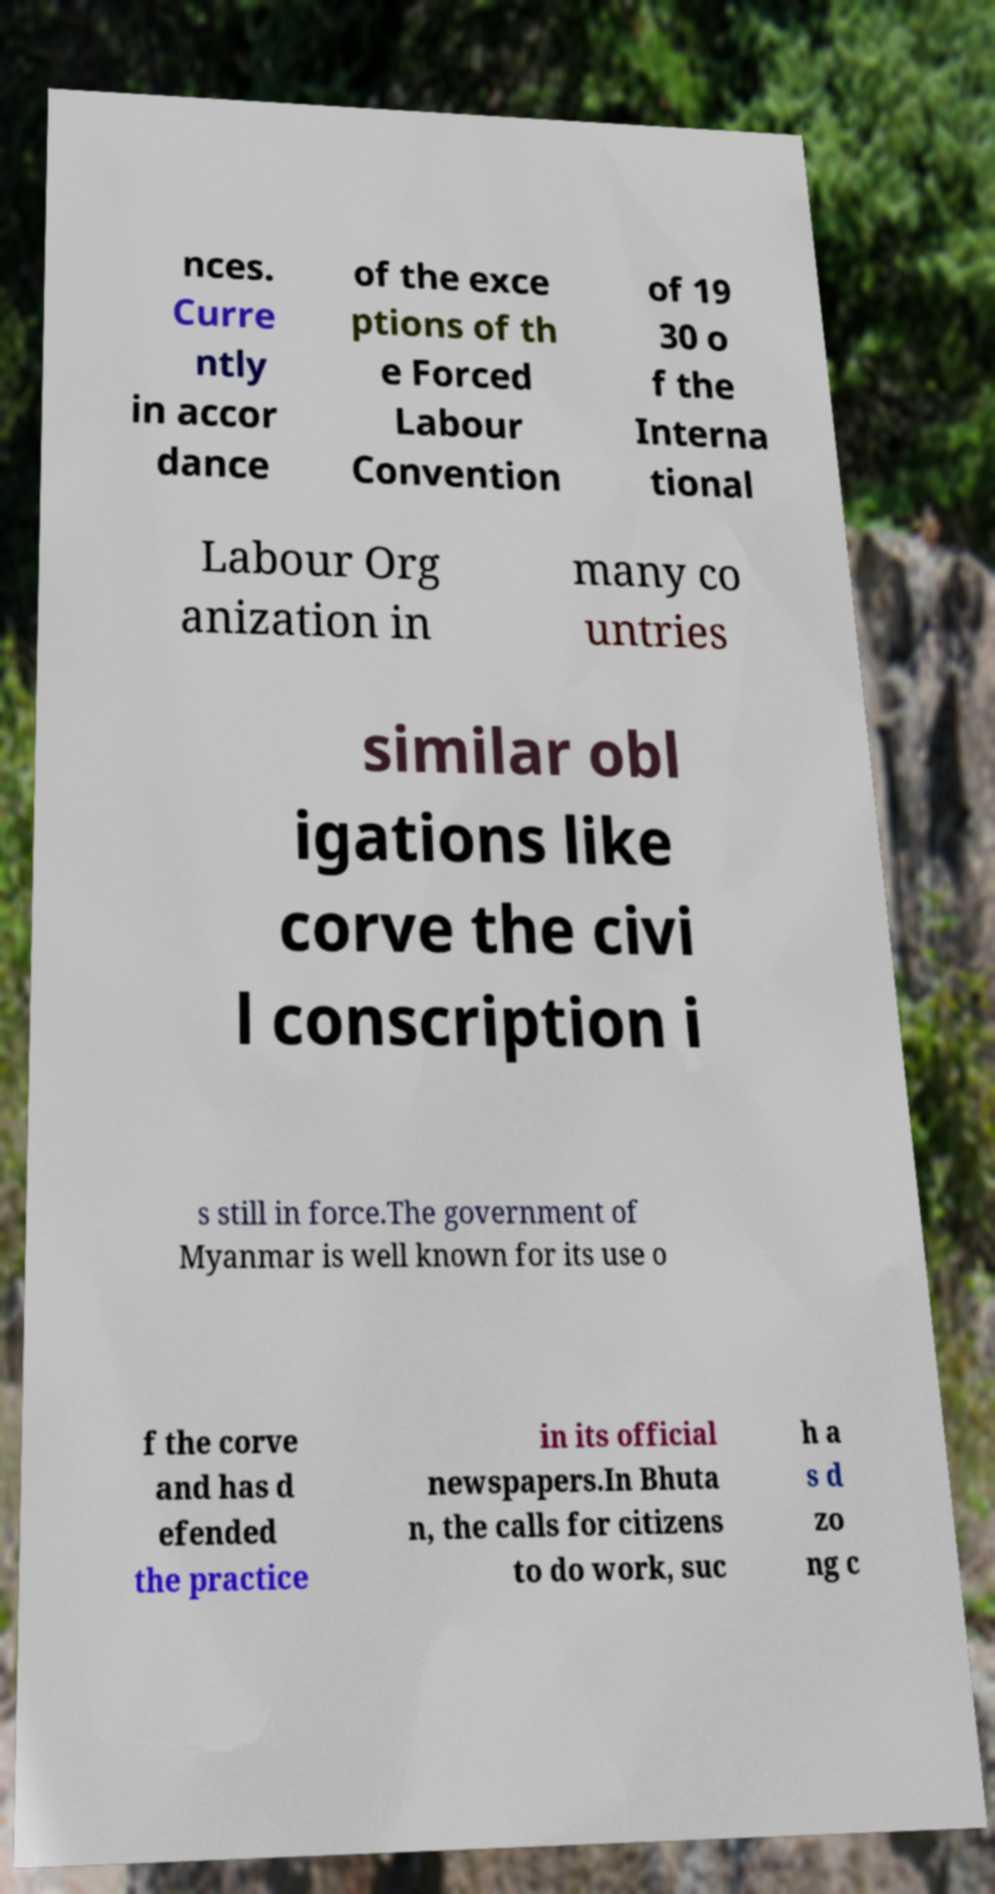What messages or text are displayed in this image? I need them in a readable, typed format. nces. Curre ntly in accor dance of the exce ptions of th e Forced Labour Convention of 19 30 o f the Interna tional Labour Org anization in many co untries similar obl igations like corve the civi l conscription i s still in force.The government of Myanmar is well known for its use o f the corve and has d efended the practice in its official newspapers.In Bhuta n, the calls for citizens to do work, suc h a s d zo ng c 